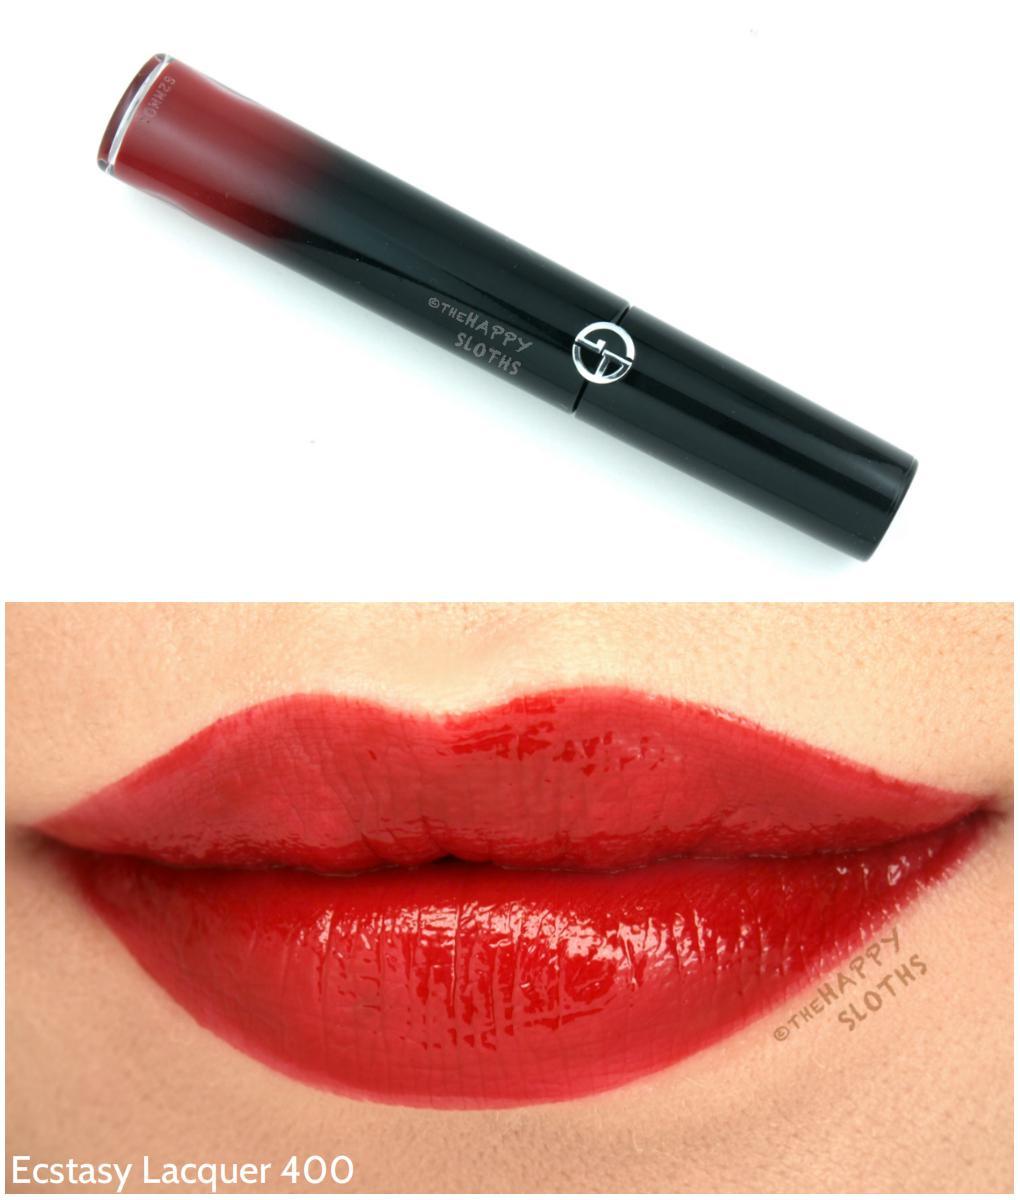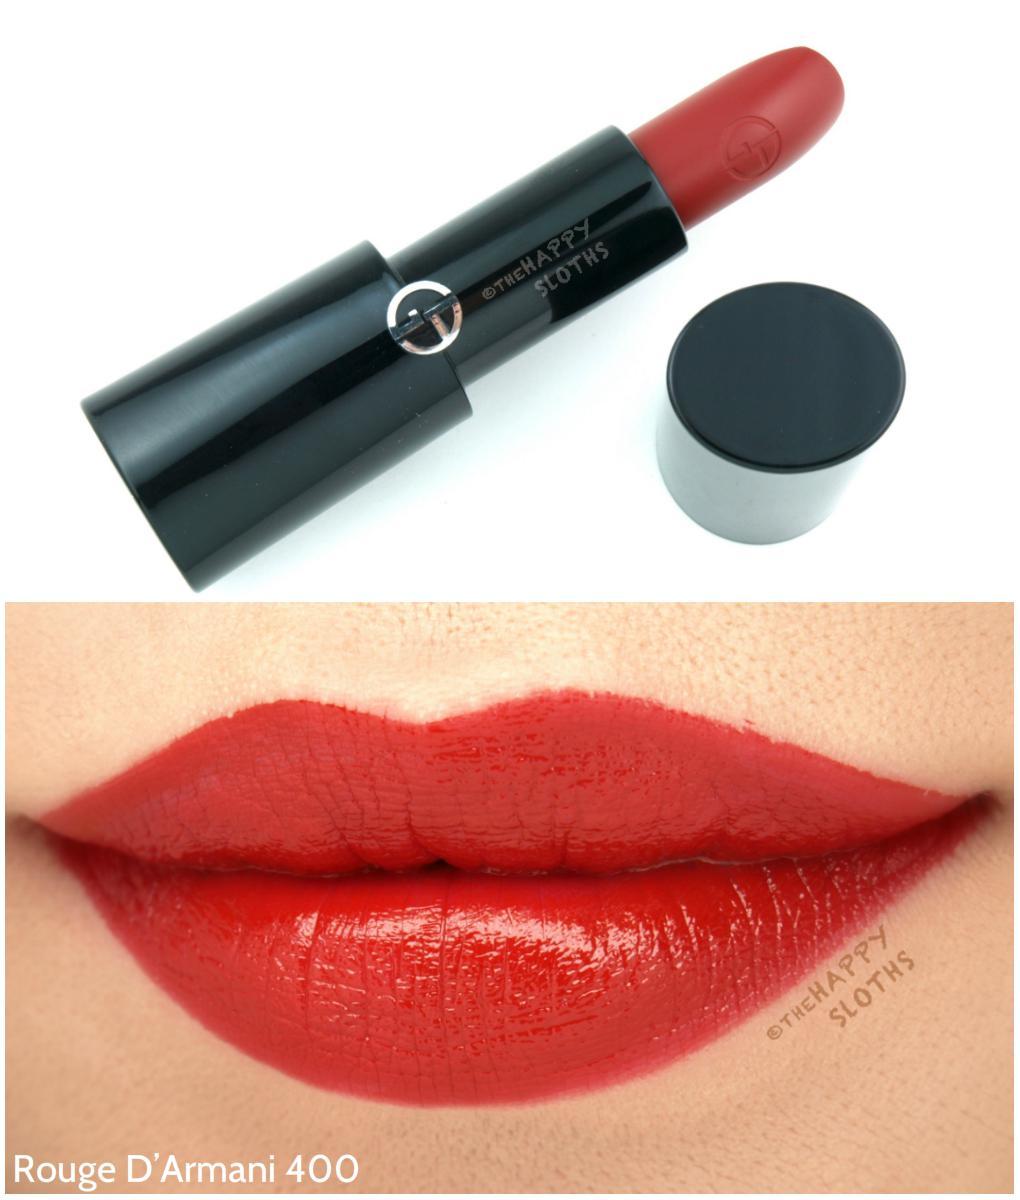The first image is the image on the left, the second image is the image on the right. Given the left and right images, does the statement "The lipstick on the left comes in a red case." hold true? Answer yes or no. No. The first image is the image on the left, the second image is the image on the right. Given the left and right images, does the statement "One image shows an unlidded tube lipstick next to a small pot with a solid-colored top, over a pair of tinted lips." hold true? Answer yes or no. Yes. 